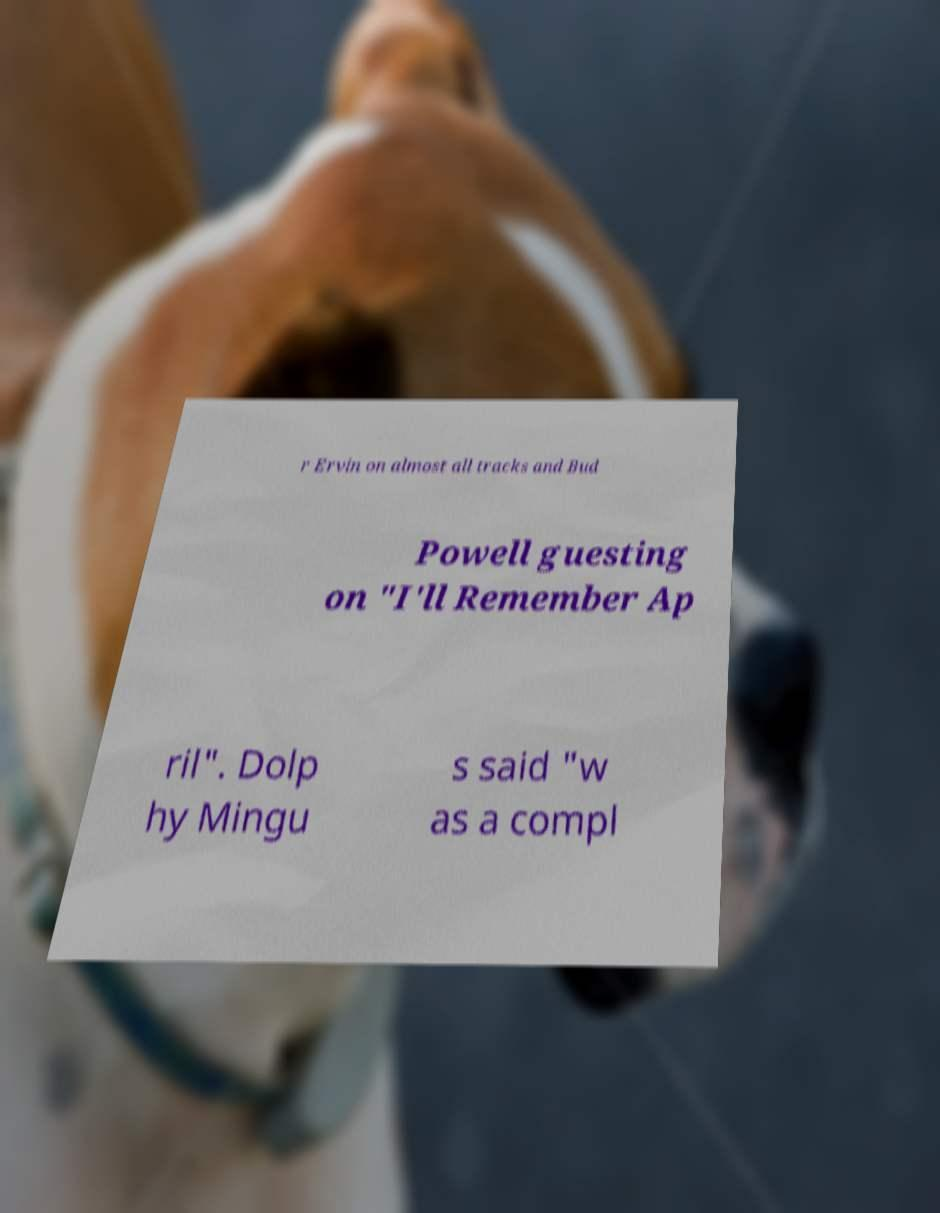There's text embedded in this image that I need extracted. Can you transcribe it verbatim? r Ervin on almost all tracks and Bud Powell guesting on "I'll Remember Ap ril". Dolp hy Mingu s said "w as a compl 